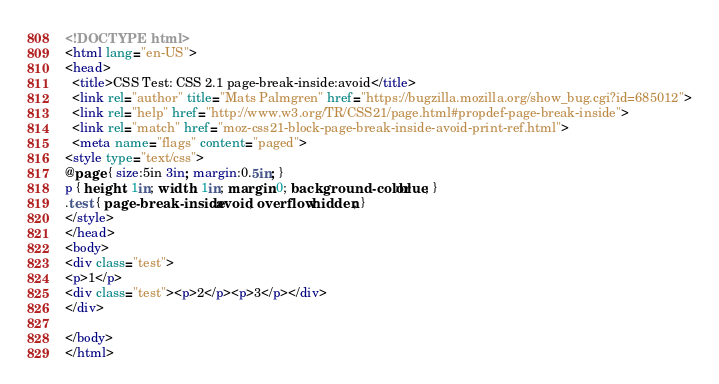Convert code to text. <code><loc_0><loc_0><loc_500><loc_500><_HTML_><!DOCTYPE html>
<html lang="en-US">
<head>
  <title>CSS Test: CSS 2.1 page-break-inside:avoid</title>
  <link rel="author" title="Mats Palmgren" href="https://bugzilla.mozilla.org/show_bug.cgi?id=685012">
  <link rel="help" href="http://www.w3.org/TR/CSS21/page.html#propdef-page-break-inside">
  <link rel="match" href="moz-css21-block-page-break-inside-avoid-print-ref.html">
  <meta name="flags" content="paged">
<style type="text/css">
@page { size:5in 3in; margin:0.5in; }
p { height: 1in; width: 1in; margin:0; background-color:blue; }
.test { page-break-inside:avoid; overflow:hidden; }
</style>
</head>
<body>
<div class="test">
<p>1</p>
<div class="test"><p>2</p><p>3</p></div>
</div>

</body>
</html>
</code> 